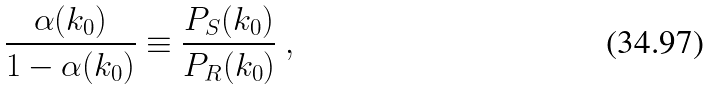<formula> <loc_0><loc_0><loc_500><loc_500>\frac { \alpha ( k _ { 0 } ) } { 1 - \alpha ( k _ { 0 } ) } \equiv \frac { P _ { S } ( k _ { 0 } ) } { P _ { R } ( k _ { 0 } ) } \ ,</formula> 